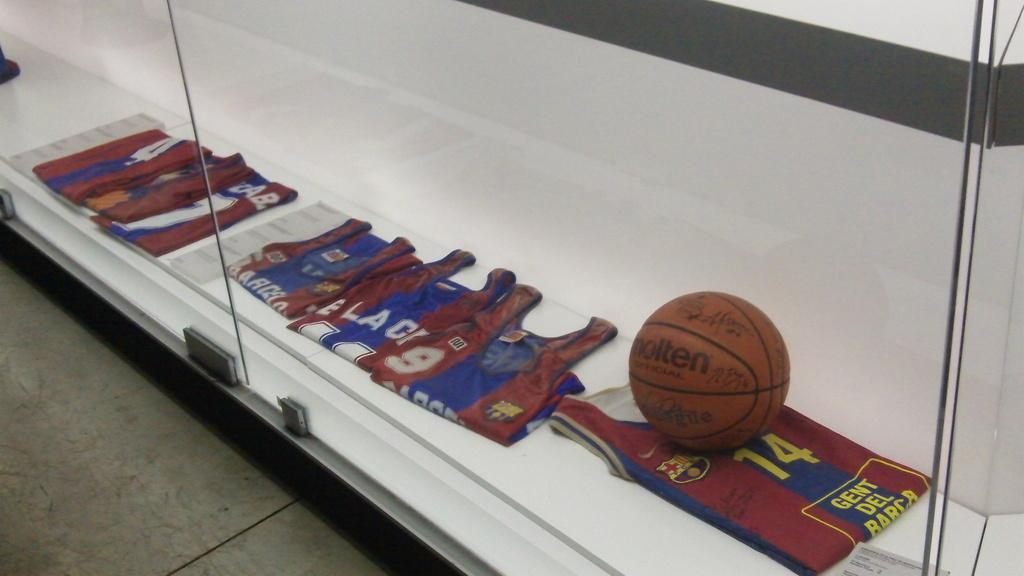<image>
Render a clear and concise summary of the photo. A molten basketball inside a glass display with basketball jerseys. 